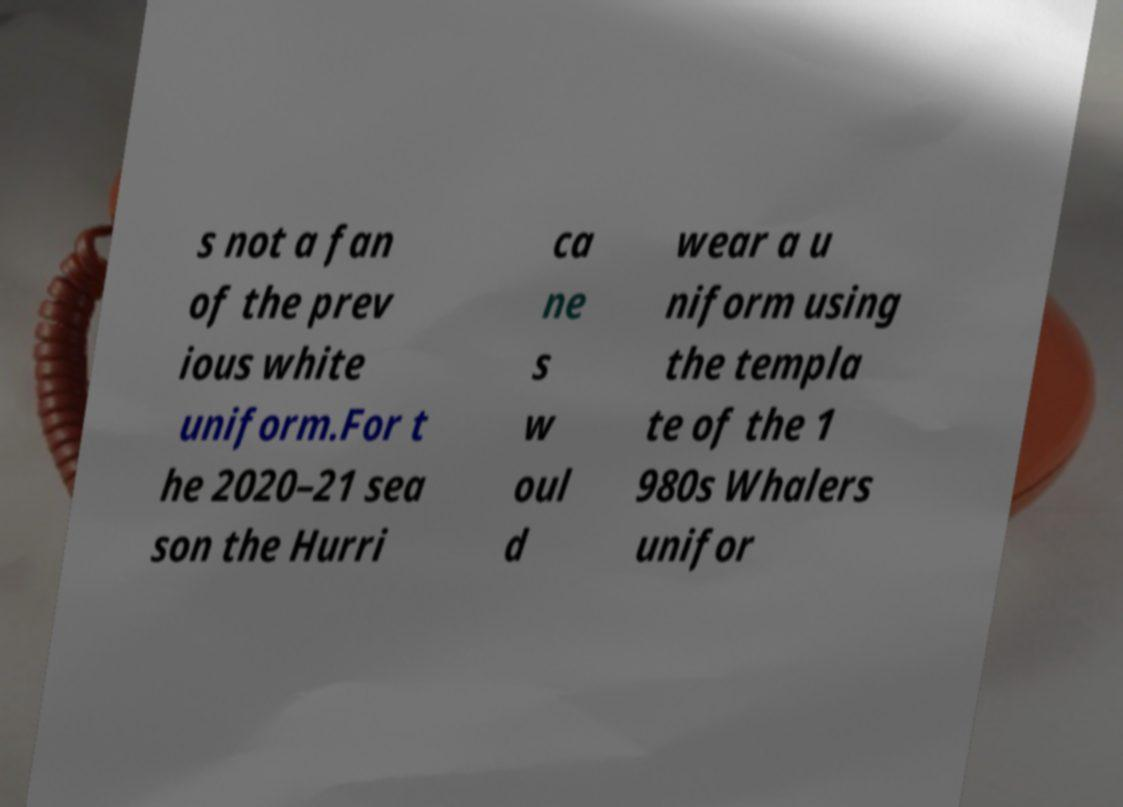Please read and relay the text visible in this image. What does it say? s not a fan of the prev ious white uniform.For t he 2020–21 sea son the Hurri ca ne s w oul d wear a u niform using the templa te of the 1 980s Whalers unifor 